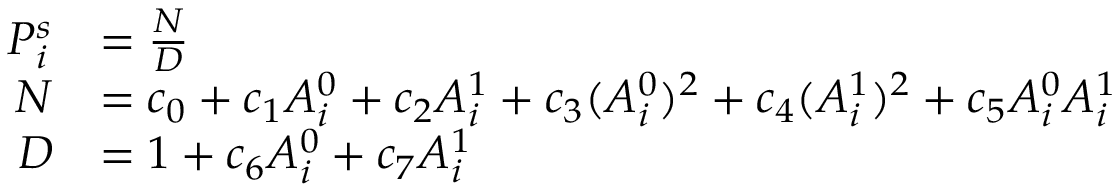<formula> <loc_0><loc_0><loc_500><loc_500>\begin{array} { r l } { P _ { i } ^ { s } } & { = \frac { N } { D } } \\ { N } & { = c _ { 0 } + c _ { 1 } A _ { i } ^ { 0 } + c _ { 2 } A _ { i } ^ { 1 } + c _ { 3 } ( A _ { i } ^ { 0 } ) ^ { 2 } + c _ { 4 } ( A _ { i } ^ { 1 } ) ^ { 2 } + c _ { 5 } A _ { i } ^ { 0 } A _ { i } ^ { 1 } } \\ { D } & { = 1 + c _ { 6 } A _ { i } ^ { 0 } + c _ { 7 } A _ { i } ^ { 1 } } \end{array}</formula> 